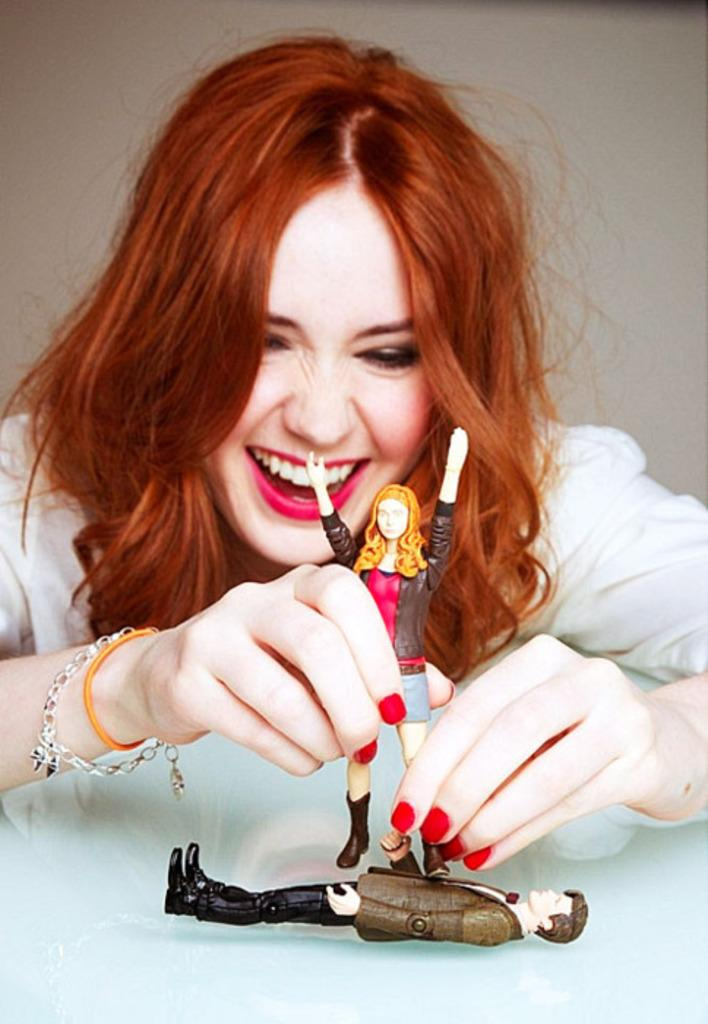Who is present in the image? There is a woman in the image. What is the woman doing in the image? The woman is smiling in the image. What object is the woman holding? The woman is holding a doll in the image. Can you describe any other objects in the image? There is a toy on a platform in the image. What type of toothpaste is the woman using in the image? There is no toothpaste present in the image; the woman is holding a doll and smiling. 